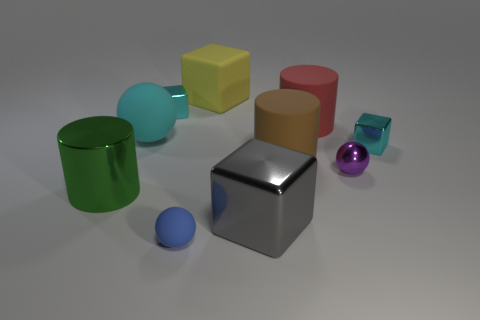Subtract all yellow balls. How many cyan blocks are left? 2 Subtract all large green metallic cylinders. How many cylinders are left? 2 Subtract 1 cylinders. How many cylinders are left? 2 Subtract all yellow blocks. How many blocks are left? 3 Subtract all purple blocks. Subtract all red balls. How many blocks are left? 4 Subtract all cylinders. How many objects are left? 7 Subtract all purple metal cylinders. Subtract all blue rubber objects. How many objects are left? 9 Add 1 red rubber things. How many red rubber things are left? 2 Add 7 large gray metal blocks. How many large gray metal blocks exist? 8 Subtract 1 purple balls. How many objects are left? 9 